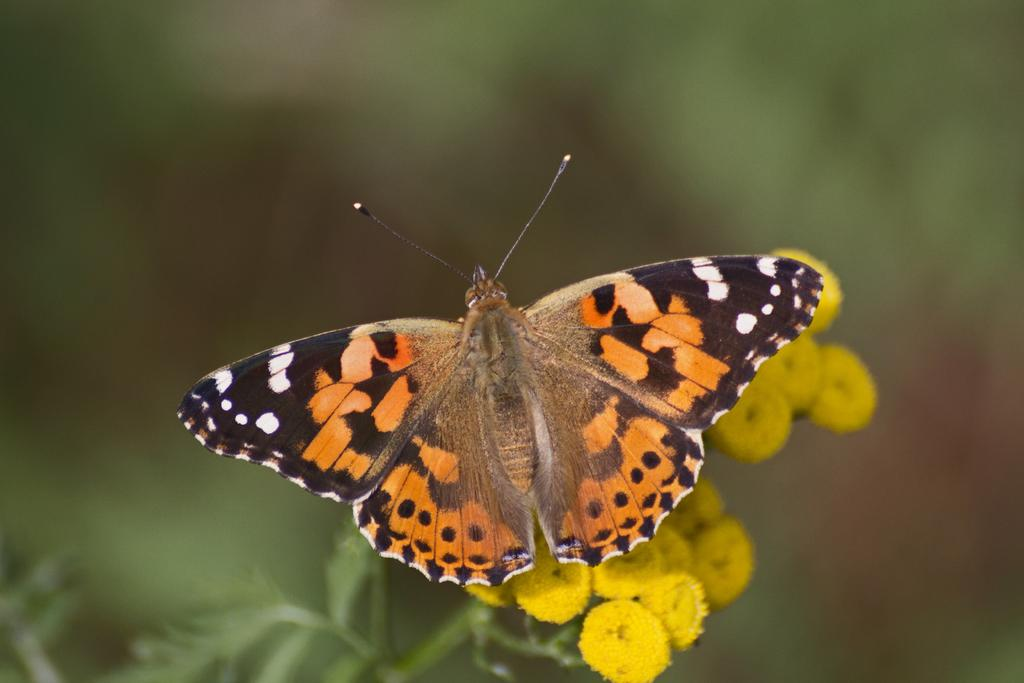What type of insect is present in the image? There is a butterfly in the image. What type of plant can be seen in the image? There is a flower plant in the image. What is the color of the flowers on the plant? The flowers are yellow in color. How would you describe the background of the image? The background of the image is blurred. What type of mint can be seen growing near the flower plant in the image? There is no mint present in the image; it only features a butterfly and a flower plant. What word is written on the butterfly's wings in the image? There are no words written on the butterfly's wings in the image; it is a natural butterfly. 